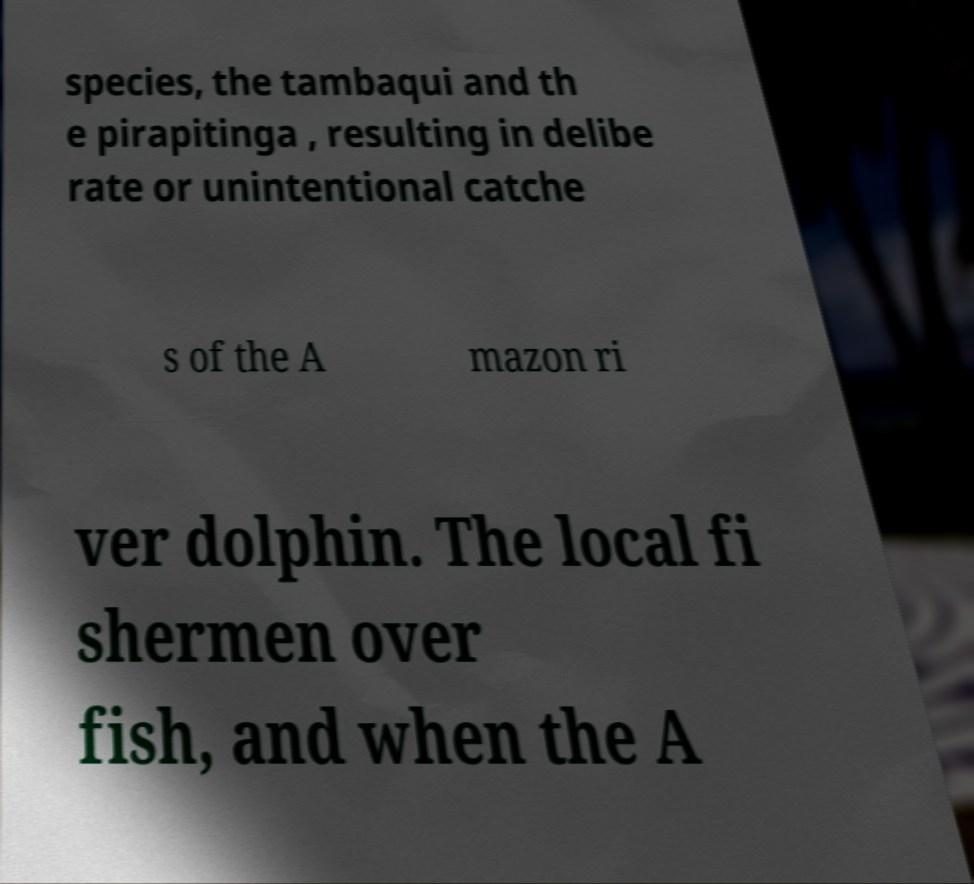Can you accurately transcribe the text from the provided image for me? species, the tambaqui and th e pirapitinga , resulting in delibe rate or unintentional catche s of the A mazon ri ver dolphin. The local fi shermen over fish, and when the A 